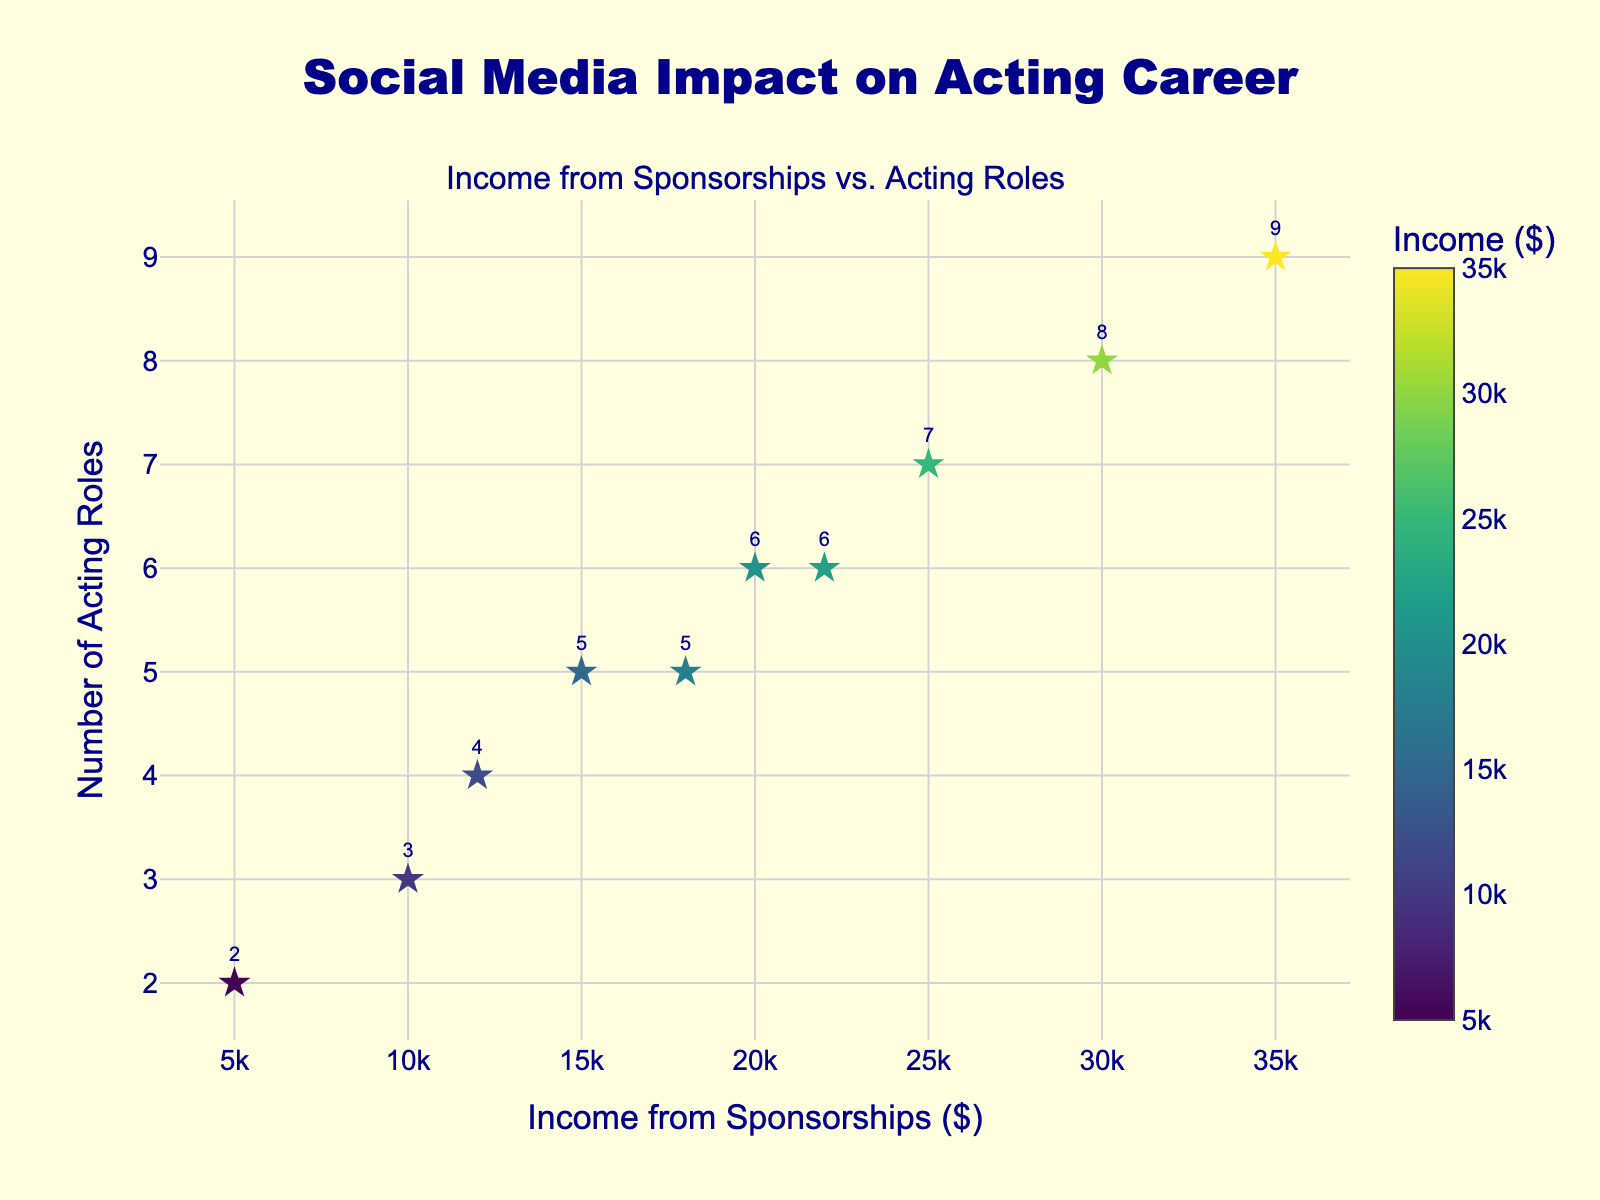What is the title of the scatter plot? The title is located at the top center of the chart and reads, "Social Media Impact on Acting Career."
Answer: Social Media Impact on Acting Career What are the labels of the x-axis and y-axis? The x-axis label is located below the x-axis, and it reads "Income from Sponsorships ($)," while the y-axis label is located to the left of the y-axis and reads "Number of Acting Roles."
Answer: Income from Sponsorships ($) and Number of Acting Roles How many data points are plotted in the scatter plot? By counting the number of markers on the plot, you can see there are 10 markers plotted.
Answer: 10 Which data point indicates the highest number of acting roles secured? Locate the marker with the highest y-value on the plot. The highest y-value is 9 acting roles.
Answer: 9 Which data point shows the lowest income from sponsorships, and what are its corresponding acting roles? Find the marker with the lowest x-value. The lowest income is $5000, and this corresponds to 2 acting roles.
Answer: $5000, 2 roles What is the general trend shown in the scatter plot between income from sponsorships and number of acting roles? Observe the directionality of the markers. More acting roles generally correlate with higher income from sponsorships.
Answer: Positive trend What is the average number of acting roles for all the data points? Add all the y-values (number of acting roles) and divide by the total number of data points: (2 + 5 + 3 + 6 + 7 + 8 + 4 + 9 + 5 + 6) / 10 = 5.5 acting roles.
Answer: 5.5 Compare the income and roles between the two points with 5 acting roles: which has a higher income and by how much? The points with 5 roles have incomes of $15000 and $18000. Subtract $15000 from $18000 to find the difference, which is $3000.
Answer: $18000; by $3000 What is the total income from sponsorships across all data points? Add all the x-values (income from sponsorships): 5000 + 15000 + 10000 + 20000 + 25000 + 30000 + 12000 + 35000 + 18000 + 22000 = $192,000.
Answer: $192,000 What color scale is used to represent the data points in the scatter plot? The color scale is indicated in the color bar, which shows a gradient from low to high values of income. The scale used is "Viridis."
Answer: Viridis 